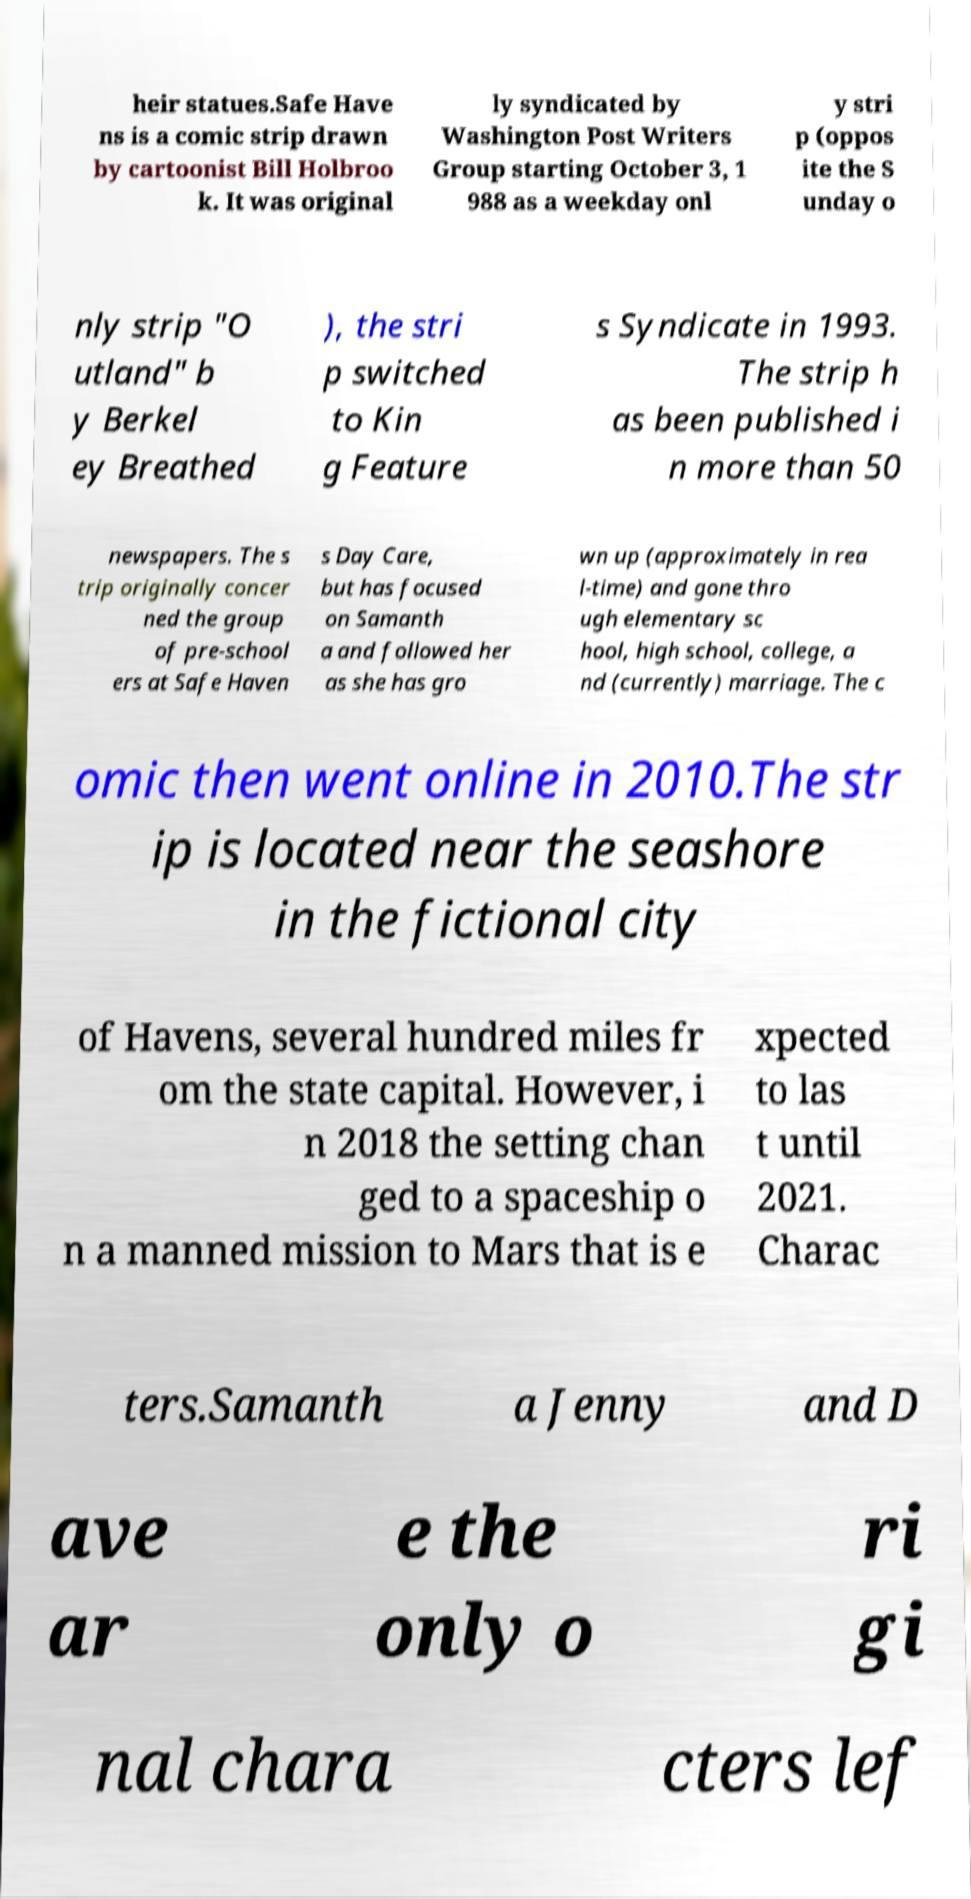There's text embedded in this image that I need extracted. Can you transcribe it verbatim? heir statues.Safe Have ns is a comic strip drawn by cartoonist Bill Holbroo k. It was original ly syndicated by Washington Post Writers Group starting October 3, 1 988 as a weekday onl y stri p (oppos ite the S unday o nly strip "O utland" b y Berkel ey Breathed ), the stri p switched to Kin g Feature s Syndicate in 1993. The strip h as been published i n more than 50 newspapers. The s trip originally concer ned the group of pre-school ers at Safe Haven s Day Care, but has focused on Samanth a and followed her as she has gro wn up (approximately in rea l-time) and gone thro ugh elementary sc hool, high school, college, a nd (currently) marriage. The c omic then went online in 2010.The str ip is located near the seashore in the fictional city of Havens, several hundred miles fr om the state capital. However, i n 2018 the setting chan ged to a spaceship o n a manned mission to Mars that is e xpected to las t until 2021. Charac ters.Samanth a Jenny and D ave ar e the only o ri gi nal chara cters lef 